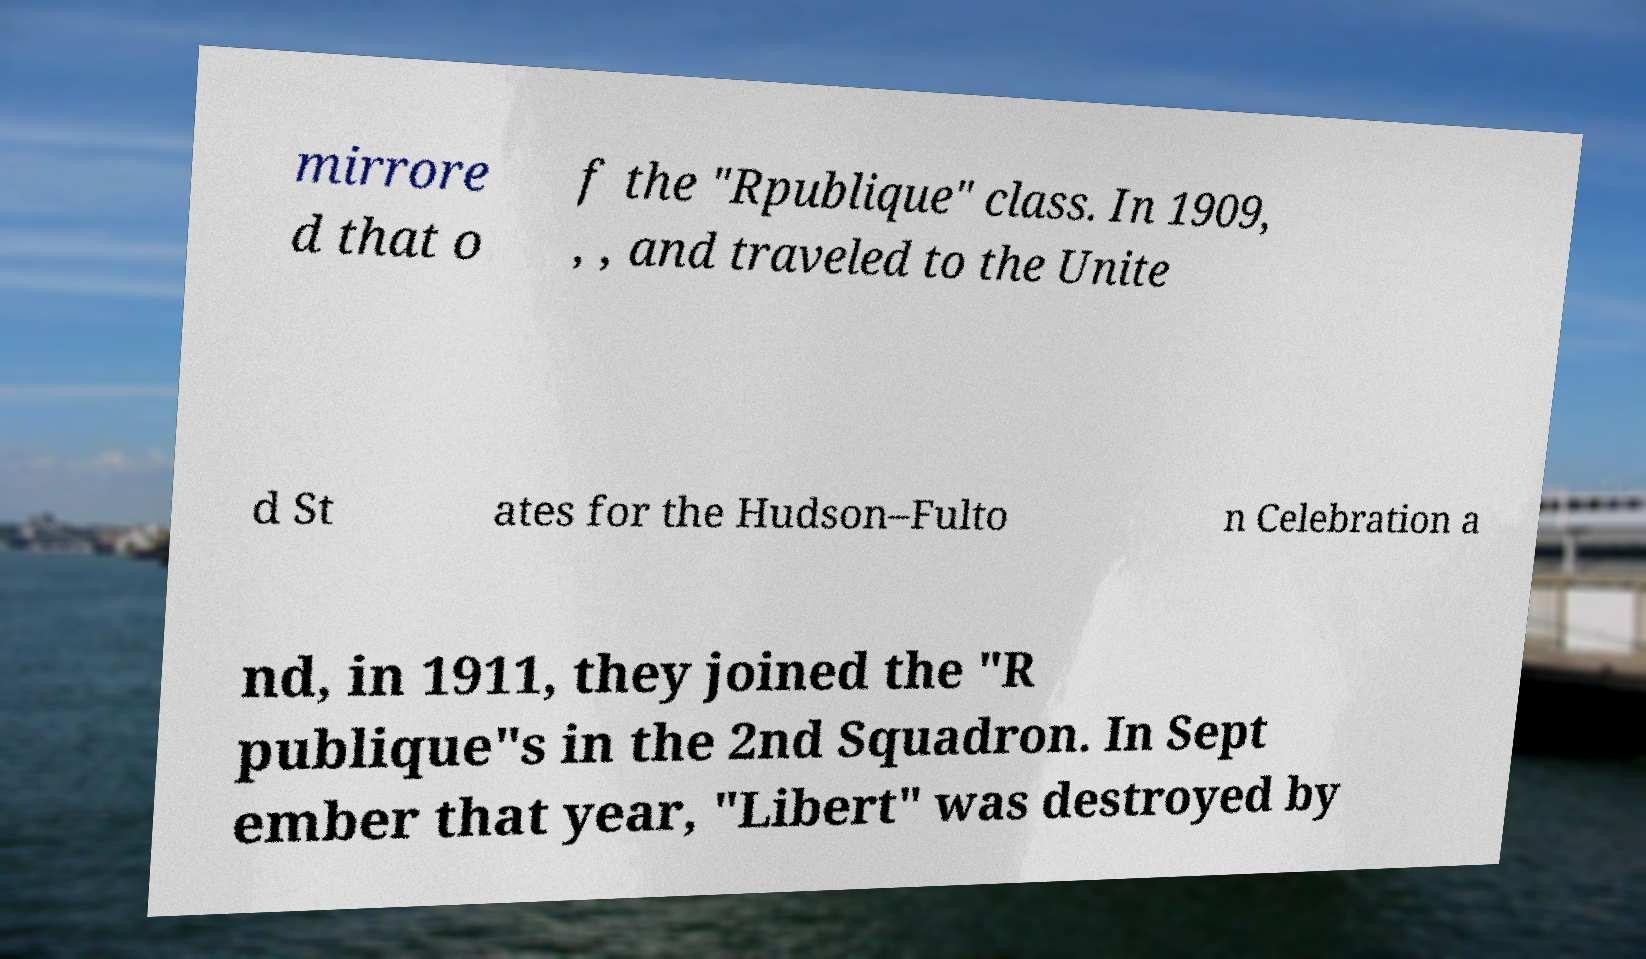Please identify and transcribe the text found in this image. mirrore d that o f the "Rpublique" class. In 1909, , , and traveled to the Unite d St ates for the Hudson–Fulto n Celebration a nd, in 1911, they joined the "R publique"s in the 2nd Squadron. In Sept ember that year, "Libert" was destroyed by 